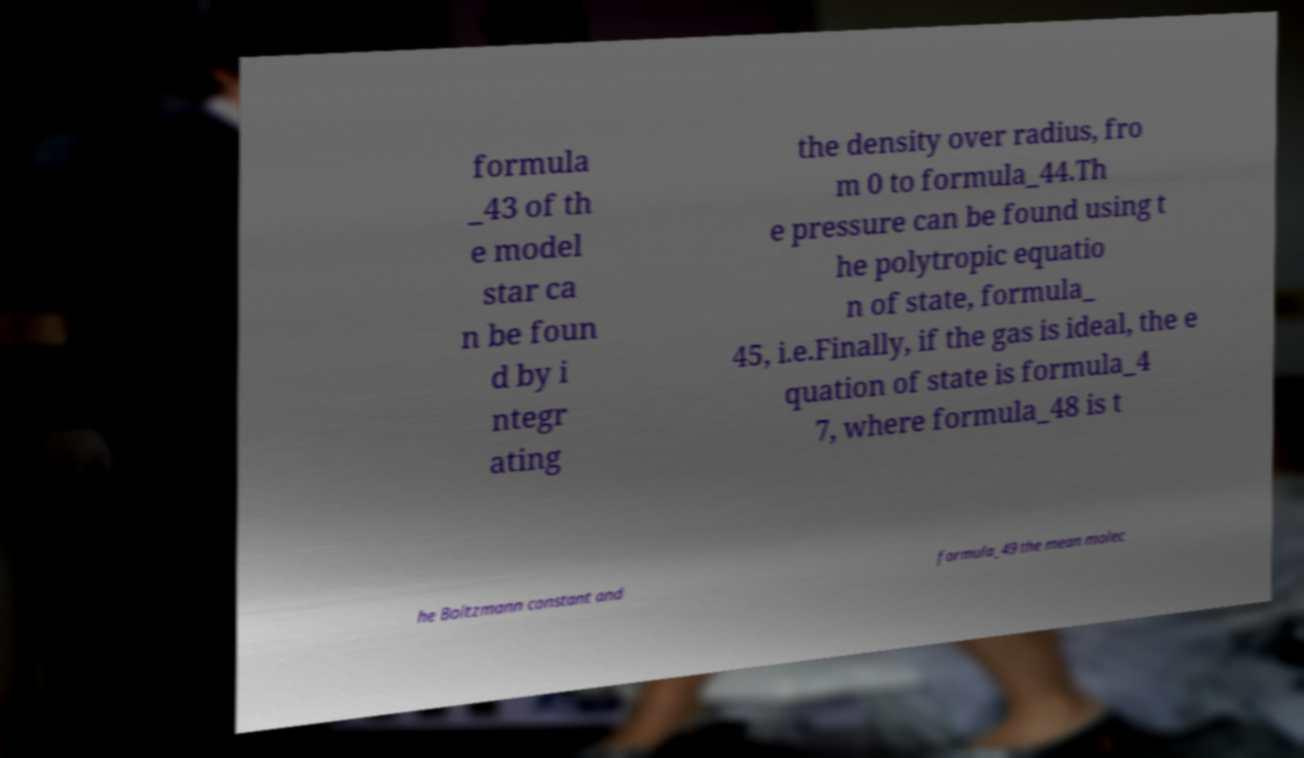Can you accurately transcribe the text from the provided image for me? formula _43 of th e model star ca n be foun d by i ntegr ating the density over radius, fro m 0 to formula_44.Th e pressure can be found using t he polytropic equatio n of state, formula_ 45, i.e.Finally, if the gas is ideal, the e quation of state is formula_4 7, where formula_48 is t he Boltzmann constant and formula_49 the mean molec 